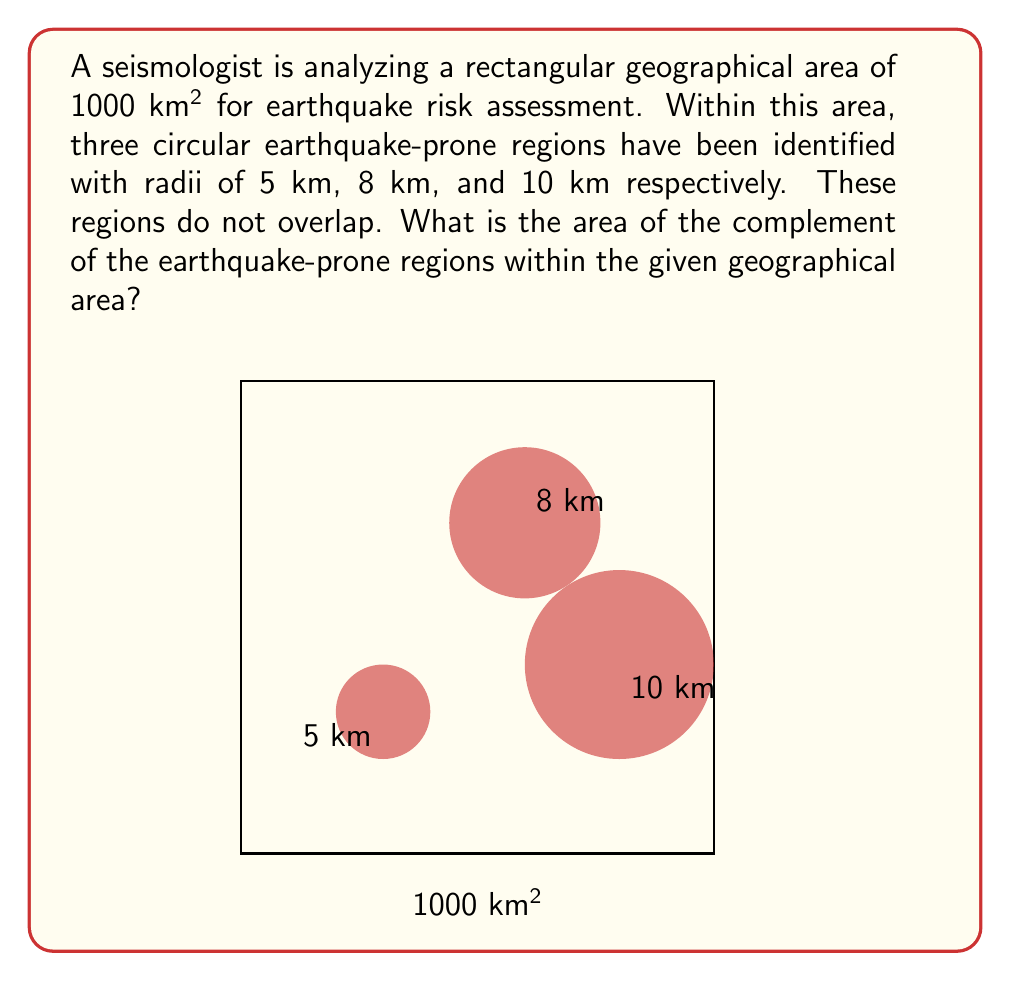Could you help me with this problem? To find the complement of the earthquake-prone regions, we need to:
1. Calculate the total area of the earthquake-prone regions
2. Subtract this area from the total geographical area

Step 1: Calculate the area of each earthquake-prone region
The area of a circle is given by the formula $A = \pi r^2$

Region 1: $A_1 = \pi (5)^2 = 25\pi$ km²
Region 2: $A_2 = \pi (8)^2 = 64\pi$ km²
Region 3: $A_3 = \pi (10)^2 = 100\pi$ km²

Step 2: Sum the areas of all earthquake-prone regions
$$A_{total} = A_1 + A_2 + A_3 = 25\pi + 64\pi + 100\pi = 189\pi \text{ km²}$$

Step 3: Convert $\pi$ to a numerical value (using 3.14159 for precision)
$$A_{total} \approx 189 \times 3.14159 \approx 593.76 \text{ km²}$$

Step 4: Calculate the complement area by subtracting from the total geographical area
$$A_{complement} = 1000 - 593.76 = 406.24 \text{ km²}$$
Answer: 406.24 km² 